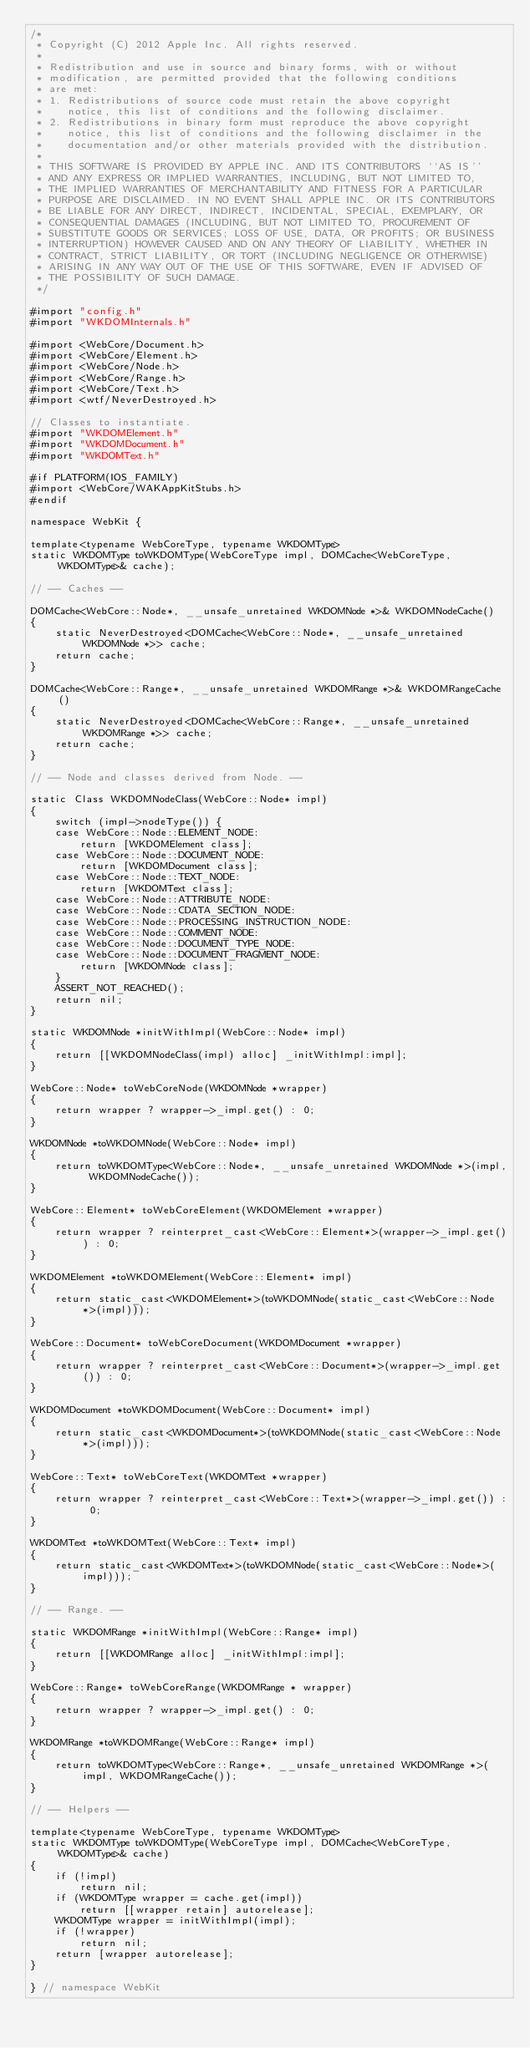<code> <loc_0><loc_0><loc_500><loc_500><_ObjectiveC_>/*
 * Copyright (C) 2012 Apple Inc. All rights reserved.
 *
 * Redistribution and use in source and binary forms, with or without
 * modification, are permitted provided that the following conditions
 * are met:
 * 1. Redistributions of source code must retain the above copyright
 *    notice, this list of conditions and the following disclaimer.
 * 2. Redistributions in binary form must reproduce the above copyright
 *    notice, this list of conditions and the following disclaimer in the
 *    documentation and/or other materials provided with the distribution.
 *
 * THIS SOFTWARE IS PROVIDED BY APPLE INC. AND ITS CONTRIBUTORS ``AS IS''
 * AND ANY EXPRESS OR IMPLIED WARRANTIES, INCLUDING, BUT NOT LIMITED TO,
 * THE IMPLIED WARRANTIES OF MERCHANTABILITY AND FITNESS FOR A PARTICULAR
 * PURPOSE ARE DISCLAIMED. IN NO EVENT SHALL APPLE INC. OR ITS CONTRIBUTORS
 * BE LIABLE FOR ANY DIRECT, INDIRECT, INCIDENTAL, SPECIAL, EXEMPLARY, OR
 * CONSEQUENTIAL DAMAGES (INCLUDING, BUT NOT LIMITED TO, PROCUREMENT OF
 * SUBSTITUTE GOODS OR SERVICES; LOSS OF USE, DATA, OR PROFITS; OR BUSINESS
 * INTERRUPTION) HOWEVER CAUSED AND ON ANY THEORY OF LIABILITY, WHETHER IN
 * CONTRACT, STRICT LIABILITY, OR TORT (INCLUDING NEGLIGENCE OR OTHERWISE)
 * ARISING IN ANY WAY OUT OF THE USE OF THIS SOFTWARE, EVEN IF ADVISED OF
 * THE POSSIBILITY OF SUCH DAMAGE.
 */

#import "config.h"
#import "WKDOMInternals.h"

#import <WebCore/Document.h>
#import <WebCore/Element.h>
#import <WebCore/Node.h>
#import <WebCore/Range.h>
#import <WebCore/Text.h>
#import <wtf/NeverDestroyed.h>

// Classes to instantiate.
#import "WKDOMElement.h"
#import "WKDOMDocument.h"
#import "WKDOMText.h"

#if PLATFORM(IOS_FAMILY)
#import <WebCore/WAKAppKitStubs.h>
#endif

namespace WebKit {

template<typename WebCoreType, typename WKDOMType>
static WKDOMType toWKDOMType(WebCoreType impl, DOMCache<WebCoreType, WKDOMType>& cache);

// -- Caches -- 

DOMCache<WebCore::Node*, __unsafe_unretained WKDOMNode *>& WKDOMNodeCache()
{
    static NeverDestroyed<DOMCache<WebCore::Node*, __unsafe_unretained WKDOMNode *>> cache;
    return cache;
}

DOMCache<WebCore::Range*, __unsafe_unretained WKDOMRange *>& WKDOMRangeCache()
{
    static NeverDestroyed<DOMCache<WebCore::Range*, __unsafe_unretained WKDOMRange *>> cache;
    return cache;
}

// -- Node and classes derived from Node. --

static Class WKDOMNodeClass(WebCore::Node* impl)
{
    switch (impl->nodeType()) {
    case WebCore::Node::ELEMENT_NODE:
        return [WKDOMElement class];
    case WebCore::Node::DOCUMENT_NODE:
        return [WKDOMDocument class];
    case WebCore::Node::TEXT_NODE:
        return [WKDOMText class];
    case WebCore::Node::ATTRIBUTE_NODE:
    case WebCore::Node::CDATA_SECTION_NODE:
    case WebCore::Node::PROCESSING_INSTRUCTION_NODE:
    case WebCore::Node::COMMENT_NODE:
    case WebCore::Node::DOCUMENT_TYPE_NODE:
    case WebCore::Node::DOCUMENT_FRAGMENT_NODE:
        return [WKDOMNode class];
    }
    ASSERT_NOT_REACHED();
    return nil;
}

static WKDOMNode *initWithImpl(WebCore::Node* impl)
{
    return [[WKDOMNodeClass(impl) alloc] _initWithImpl:impl];
}

WebCore::Node* toWebCoreNode(WKDOMNode *wrapper)
{
    return wrapper ? wrapper->_impl.get() : 0;
}

WKDOMNode *toWKDOMNode(WebCore::Node* impl)
{
    return toWKDOMType<WebCore::Node*, __unsafe_unretained WKDOMNode *>(impl, WKDOMNodeCache());
}

WebCore::Element* toWebCoreElement(WKDOMElement *wrapper)
{
    return wrapper ? reinterpret_cast<WebCore::Element*>(wrapper->_impl.get()) : 0;
}

WKDOMElement *toWKDOMElement(WebCore::Element* impl)
{
    return static_cast<WKDOMElement*>(toWKDOMNode(static_cast<WebCore::Node*>(impl)));
}

WebCore::Document* toWebCoreDocument(WKDOMDocument *wrapper)
{
    return wrapper ? reinterpret_cast<WebCore::Document*>(wrapper->_impl.get()) : 0;
}

WKDOMDocument *toWKDOMDocument(WebCore::Document* impl)
{
    return static_cast<WKDOMDocument*>(toWKDOMNode(static_cast<WebCore::Node*>(impl)));
}

WebCore::Text* toWebCoreText(WKDOMText *wrapper)
{
    return wrapper ? reinterpret_cast<WebCore::Text*>(wrapper->_impl.get()) : 0;
}

WKDOMText *toWKDOMText(WebCore::Text* impl)
{
    return static_cast<WKDOMText*>(toWKDOMNode(static_cast<WebCore::Node*>(impl)));
}

// -- Range. --

static WKDOMRange *initWithImpl(WebCore::Range* impl)
{
    return [[WKDOMRange alloc] _initWithImpl:impl];
}

WebCore::Range* toWebCoreRange(WKDOMRange * wrapper)
{
    return wrapper ? wrapper->_impl.get() : 0;
}

WKDOMRange *toWKDOMRange(WebCore::Range* impl)
{
    return toWKDOMType<WebCore::Range*, __unsafe_unretained WKDOMRange *>(impl, WKDOMRangeCache());
}

// -- Helpers --

template<typename WebCoreType, typename WKDOMType>
static WKDOMType toWKDOMType(WebCoreType impl, DOMCache<WebCoreType, WKDOMType>& cache)
{
    if (!impl)
        return nil;
    if (WKDOMType wrapper = cache.get(impl))
        return [[wrapper retain] autorelease];
    WKDOMType wrapper = initWithImpl(impl);
    if (!wrapper)
        return nil;
    return [wrapper autorelease];
}

} // namespace WebKit
</code> 